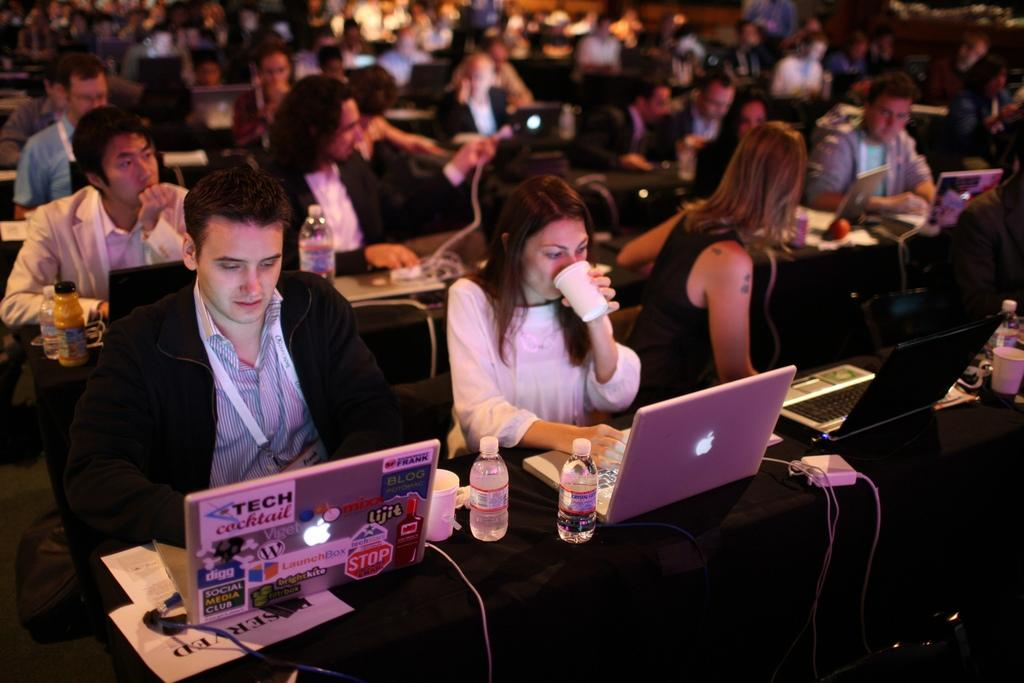What are the people in the image doing? The people in the image are sitting on chairs. What are the chairs facing in the image? The chairs are in front of tables. What electronic devices can be seen on the tables? There are laptops on the tables. What else can be seen on the tables besides laptops? There are bottles, glasses, wires, and other objects on the tables. Can you describe the background of the image? The background of the image is blurred. What type of plants are growing on the tables in the image? There are no plants visible on the tables in the image. What color is the marble on the chairs in the image? There is no marble present on the chairs in the image. 